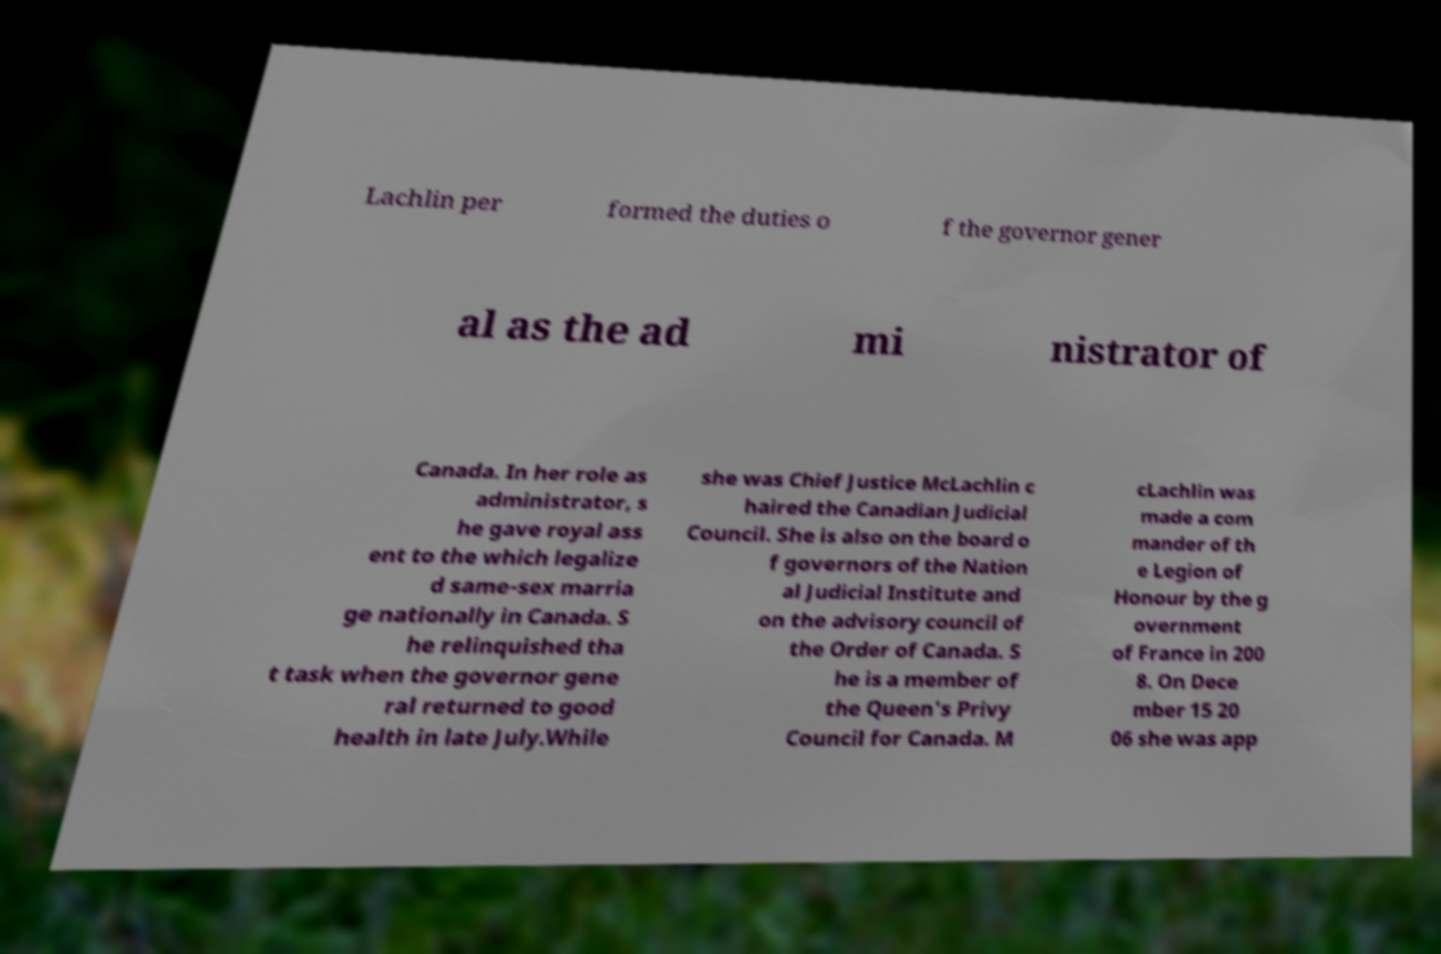What messages or text are displayed in this image? I need them in a readable, typed format. Lachlin per formed the duties o f the governor gener al as the ad mi nistrator of Canada. In her role as administrator, s he gave royal ass ent to the which legalize d same-sex marria ge nationally in Canada. S he relinquished tha t task when the governor gene ral returned to good health in late July.While she was Chief Justice McLachlin c haired the Canadian Judicial Council. She is also on the board o f governors of the Nation al Judicial Institute and on the advisory council of the Order of Canada. S he is a member of the Queen's Privy Council for Canada. M cLachlin was made a com mander of th e Legion of Honour by the g overnment of France in 200 8. On Dece mber 15 20 06 she was app 